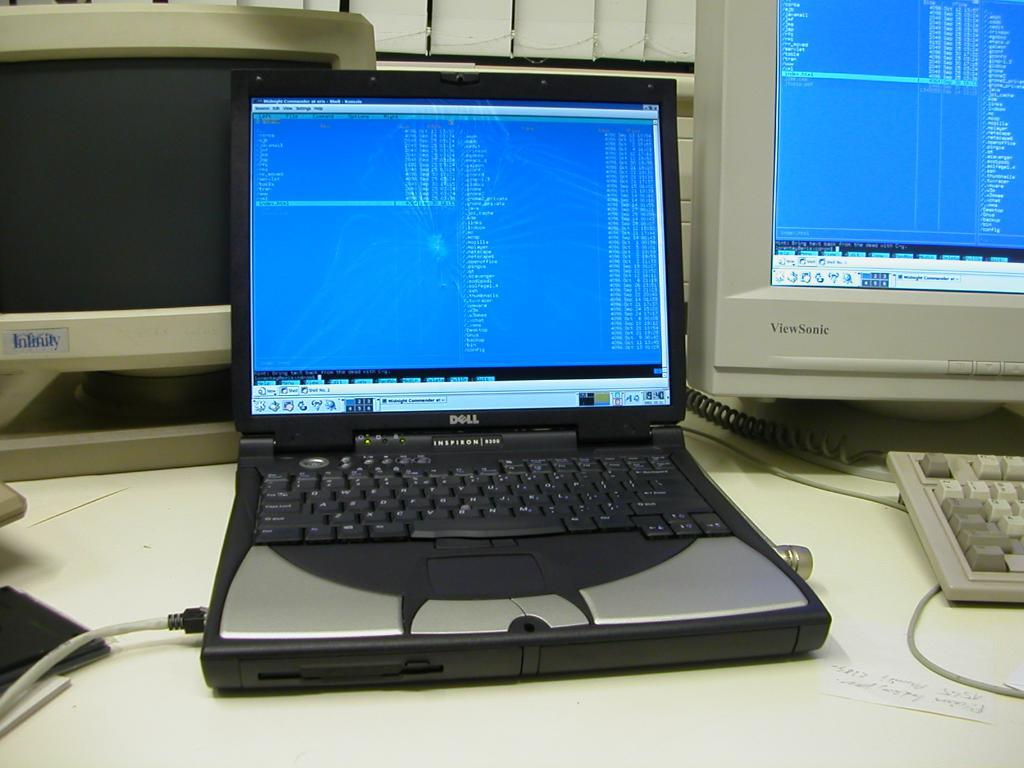<image>
Describe the image concisely. An open laptop is a Dell Inspiron brand. 